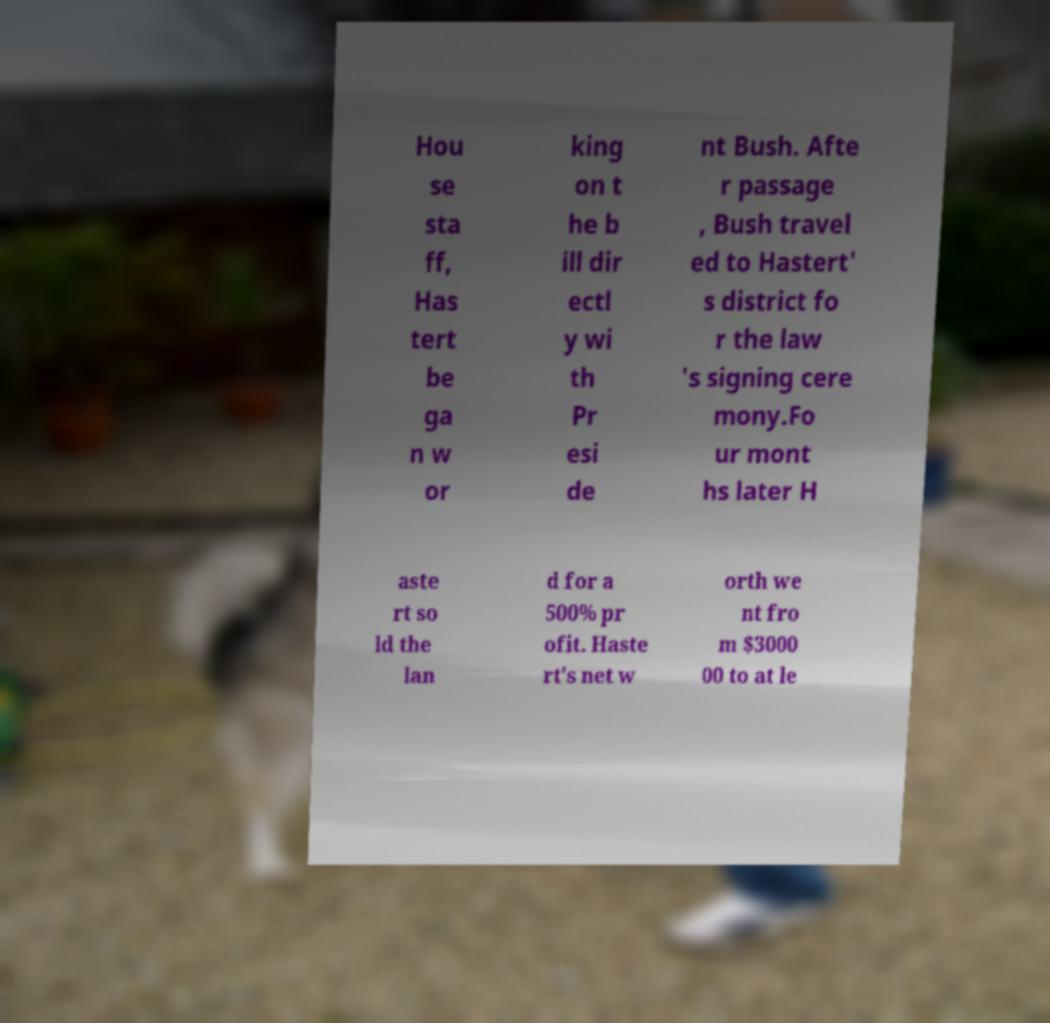Please identify and transcribe the text found in this image. Hou se sta ff, Has tert be ga n w or king on t he b ill dir ectl y wi th Pr esi de nt Bush. Afte r passage , Bush travel ed to Hastert' s district fo r the law 's signing cere mony.Fo ur mont hs later H aste rt so ld the lan d for a 500% pr ofit. Haste rt's net w orth we nt fro m $3000 00 to at le 